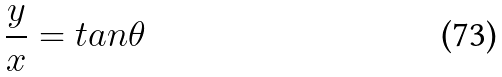<formula> <loc_0><loc_0><loc_500><loc_500>\frac { y } { x } = t a n \theta</formula> 